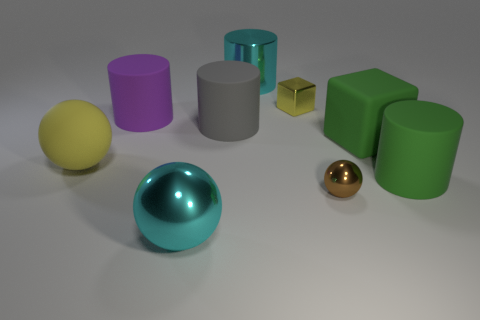Subtract all large cyan cylinders. How many cylinders are left? 3 Add 1 tiny blocks. How many objects exist? 10 Subtract 4 cylinders. How many cylinders are left? 0 Subtract all cubes. How many objects are left? 7 Subtract all brown balls. How many balls are left? 2 Subtract 1 yellow balls. How many objects are left? 8 Subtract all purple cubes. Subtract all gray cylinders. How many cubes are left? 2 Subtract all blue cylinders. How many purple spheres are left? 0 Subtract all large cyan shiny spheres. Subtract all big blocks. How many objects are left? 7 Add 1 small balls. How many small balls are left? 2 